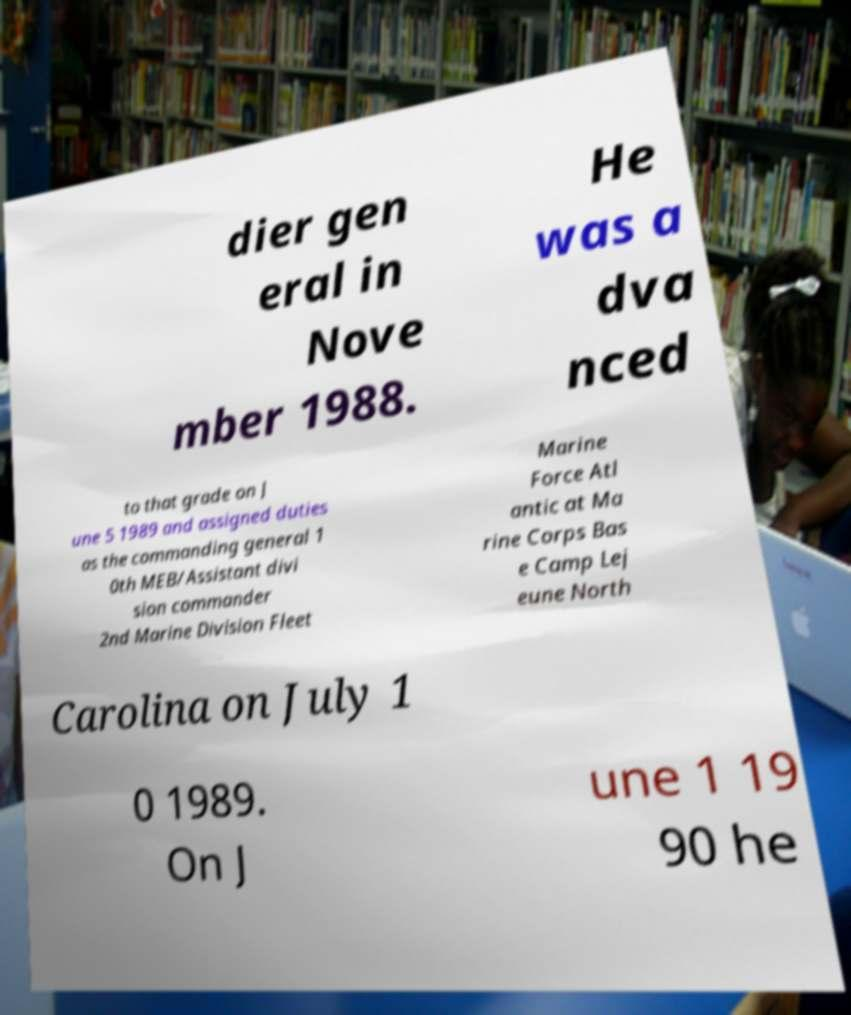I need the written content from this picture converted into text. Can you do that? dier gen eral in Nove mber 1988. He was a dva nced to that grade on J une 5 1989 and assigned duties as the commanding general 1 0th MEB/Assistant divi sion commander 2nd Marine Division Fleet Marine Force Atl antic at Ma rine Corps Bas e Camp Lej eune North Carolina on July 1 0 1989. On J une 1 19 90 he 